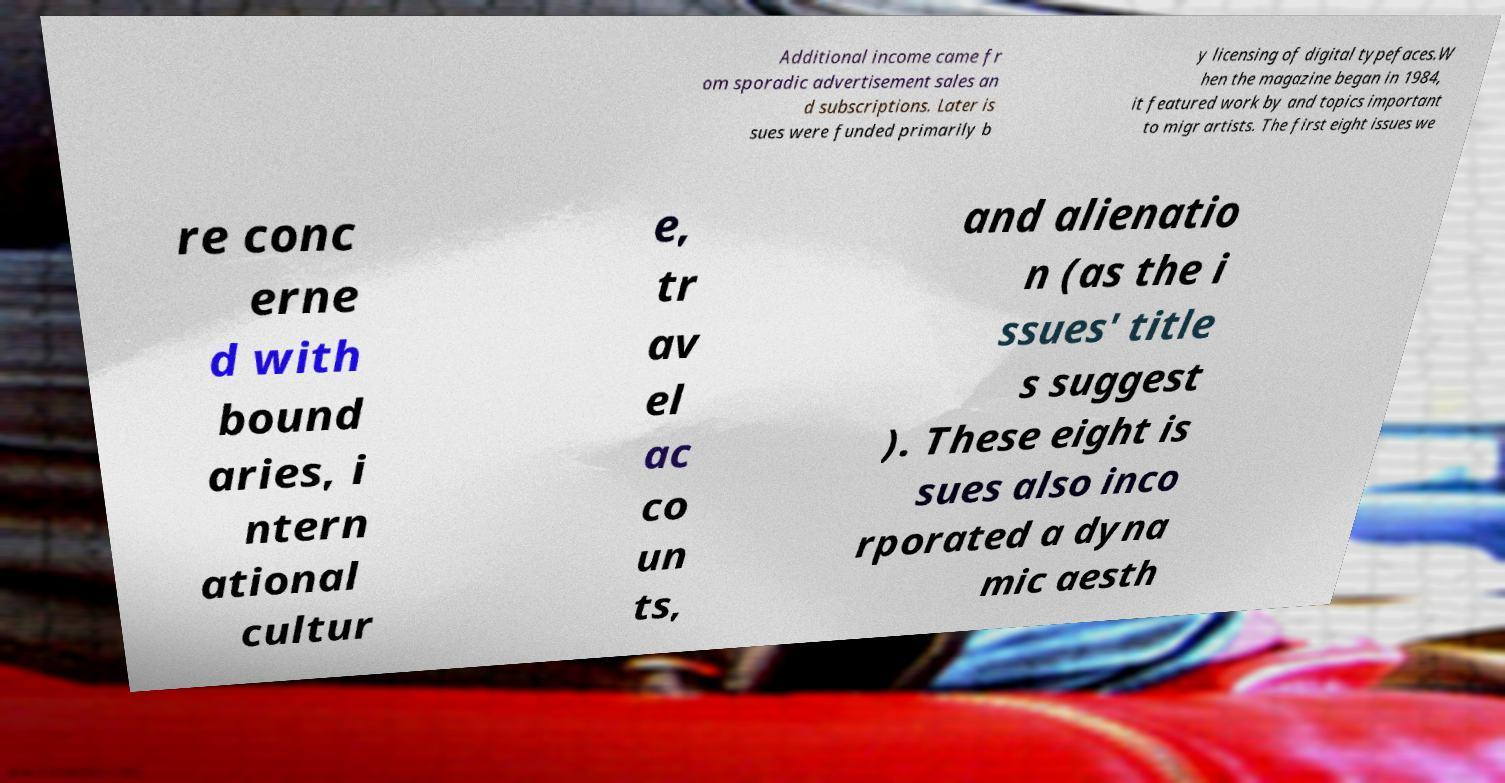I need the written content from this picture converted into text. Can you do that? Additional income came fr om sporadic advertisement sales an d subscriptions. Later is sues were funded primarily b y licensing of digital typefaces.W hen the magazine began in 1984, it featured work by and topics important to migr artists. The first eight issues we re conc erne d with bound aries, i ntern ational cultur e, tr av el ac co un ts, and alienatio n (as the i ssues' title s suggest ). These eight is sues also inco rporated a dyna mic aesth 